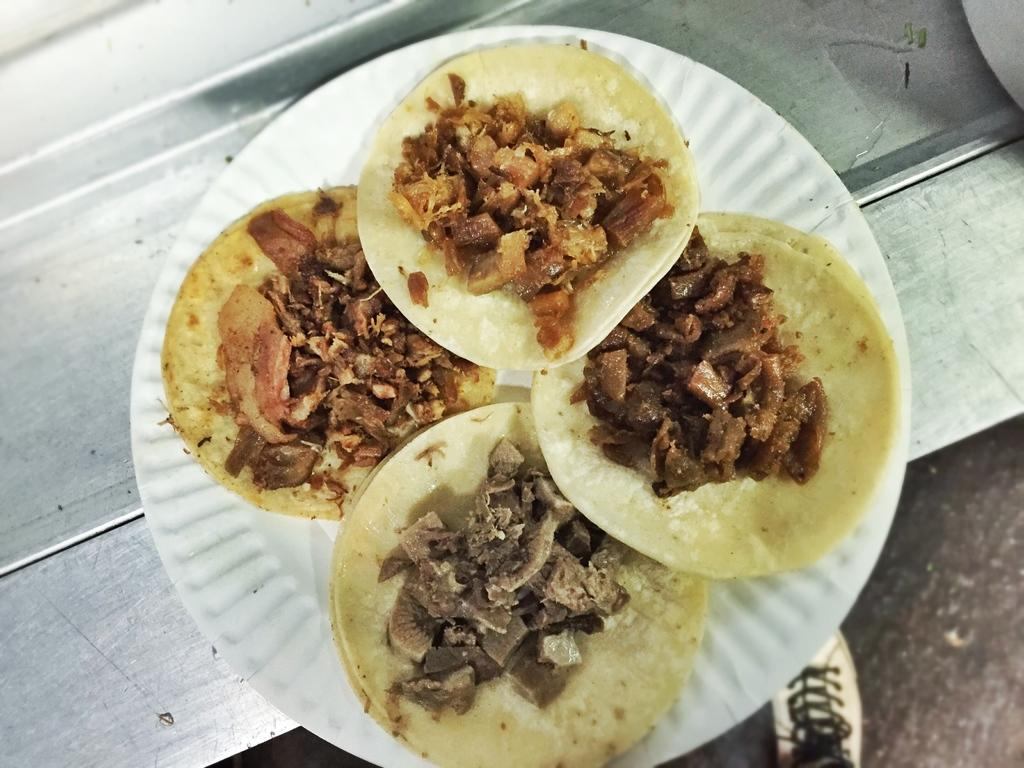What is on the plate that is visible in the image? There are food items on a plate in the image. Where is the plate located in the image? The plate is placed on a table in the image. What other object can be seen in the image besides the plate and food? There is a shoe visible in the image. What part of the room can be seen in the image? The floor is visible in the image. What type of nerve can be seen in the image? There is no nerve present in the image; it features a plate with food items, a shoe, and a visible floor. 